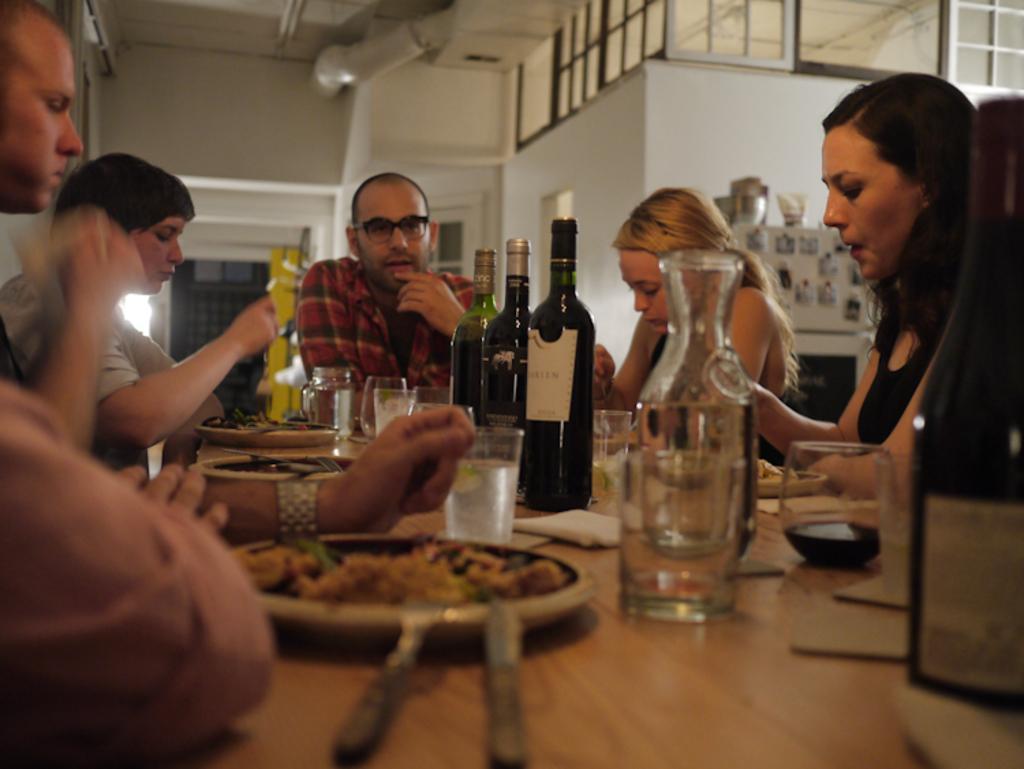Can you describe this image briefly? There are few people sitting. this is the table. There are three bottles,glass jar,tumblers,and plates placed on the table. At background I can see white color object with some photos attached. This looks like the door. i think these are the windows with glass doors. This looks like the piper at the rooftop. 